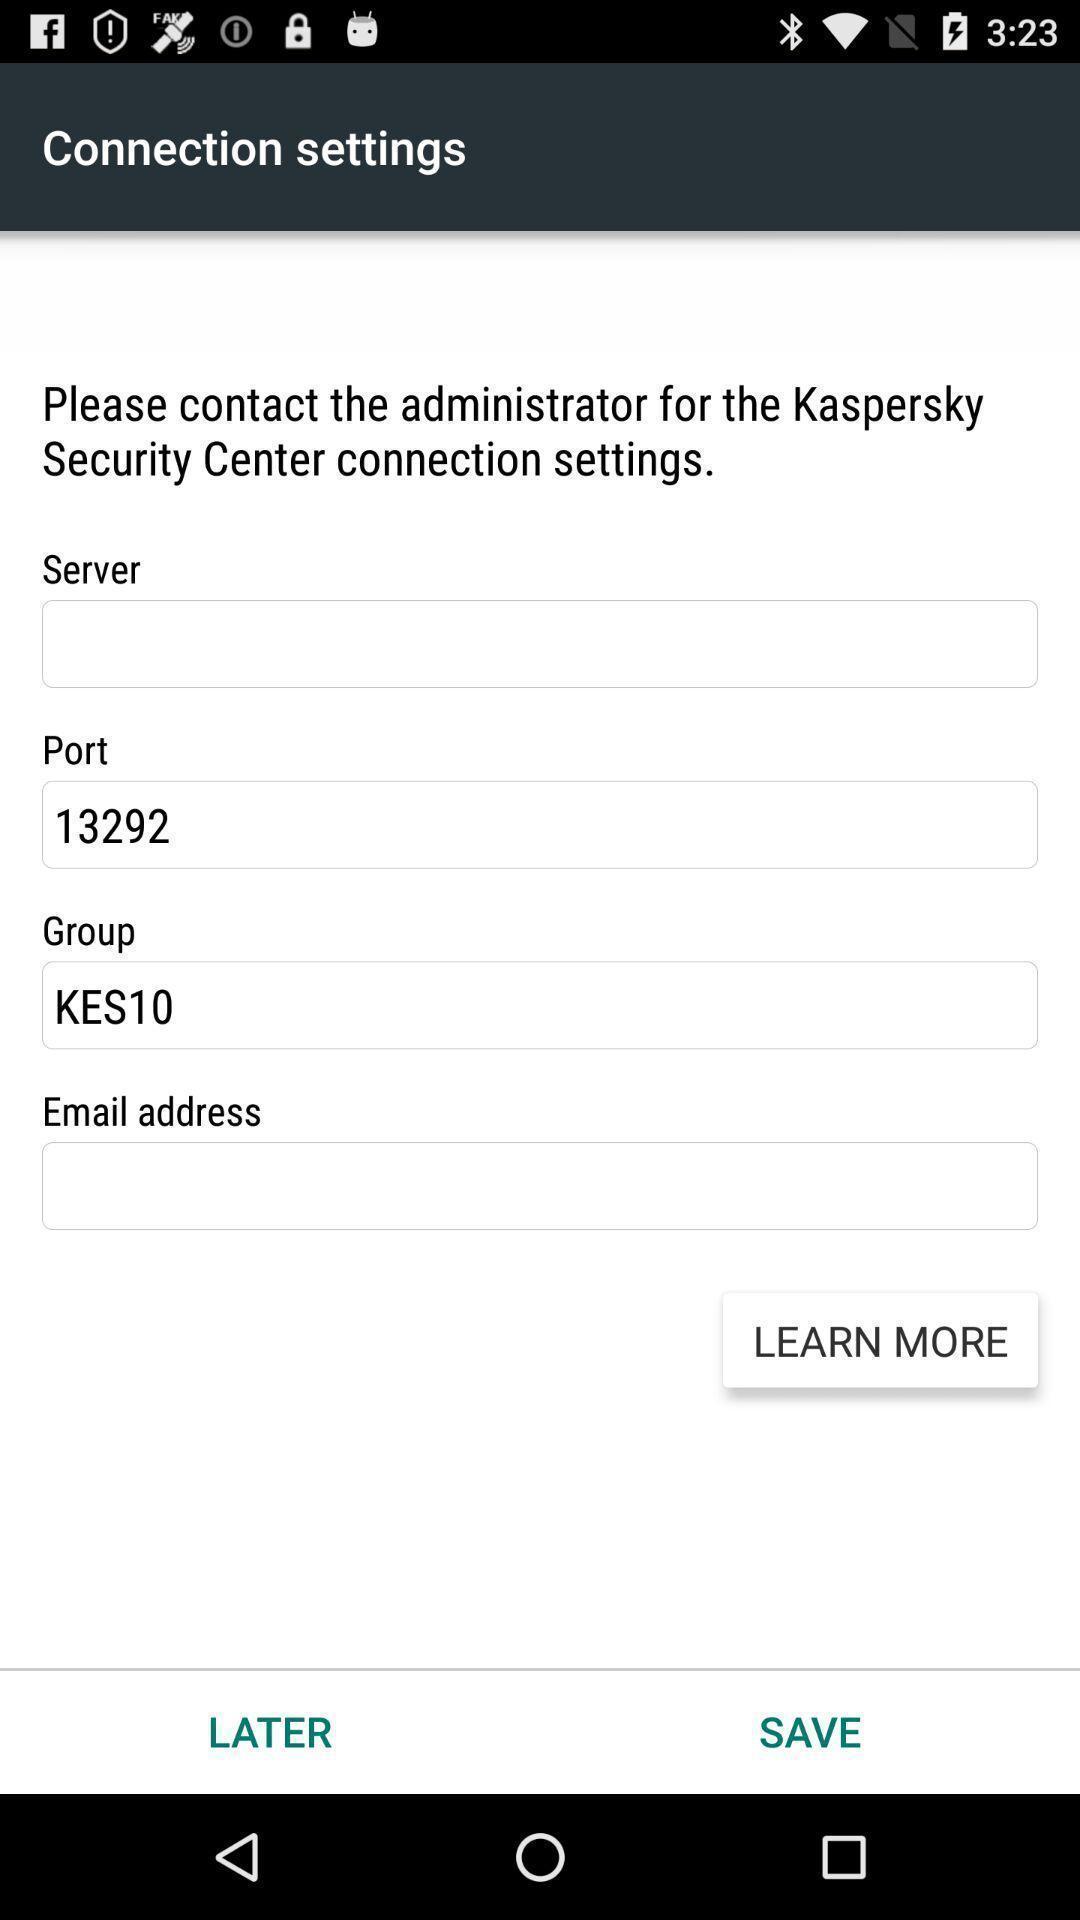Give me a narrative description of this picture. Settings for connections of a security app. 